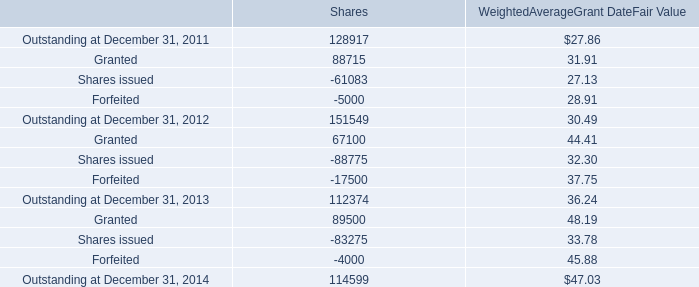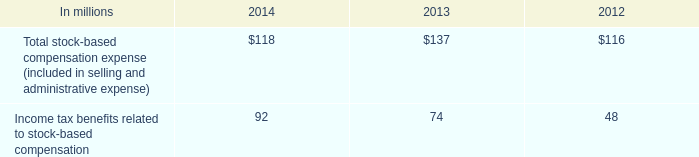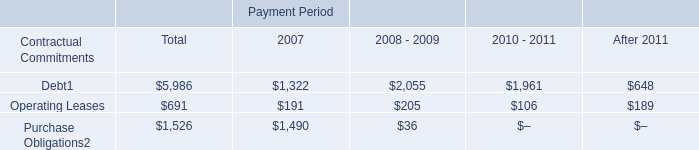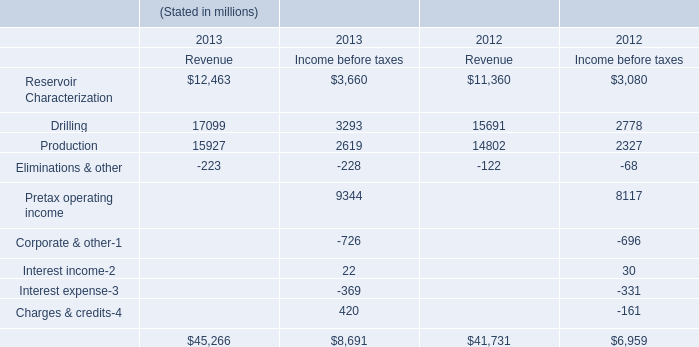What is the growing rate of Drilling for Revenue in the years with the least Production for Revenue? 
Computations: ((17099 - 15691) / 15691)
Answer: 0.08973. 